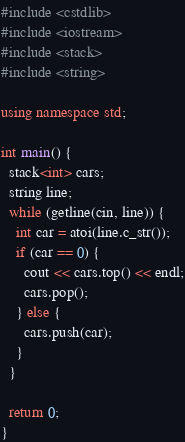Convert code to text. <code><loc_0><loc_0><loc_500><loc_500><_C++_>#include <cstdlib>
#include <iostream>
#include <stack>
#include <string>

using namespace std;

int main() {
  stack<int> cars;
  string line;
  while (getline(cin, line)) {
    int car = atoi(line.c_str());
    if (car == 0) {
      cout << cars.top() << endl;
      cars.pop();
    } else {
      cars.push(car);
    }
  }

  return 0;
}</code> 